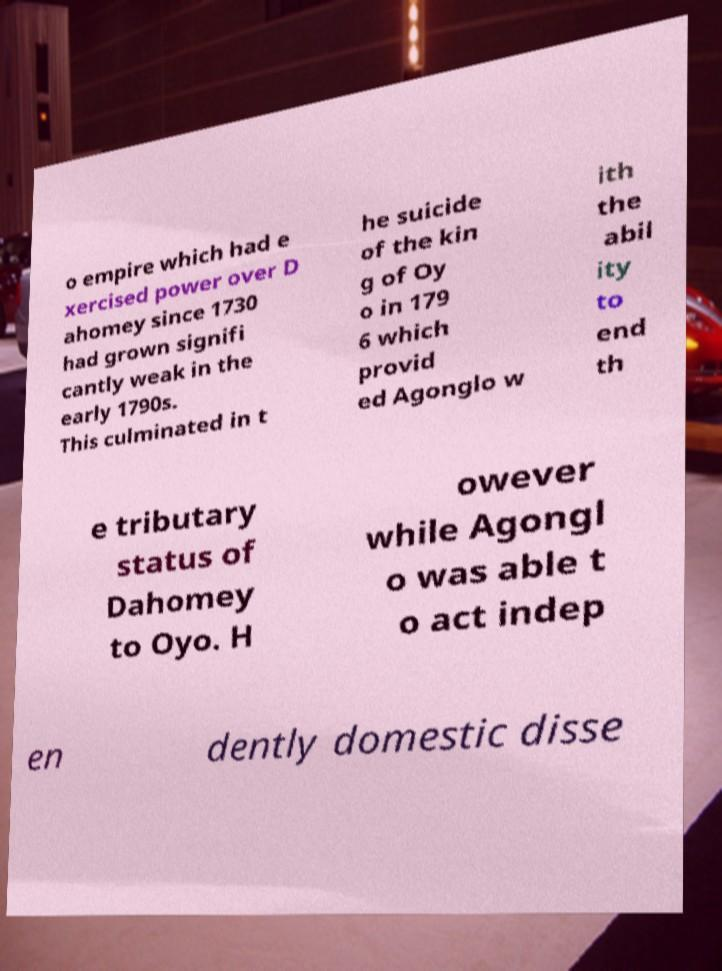Please read and relay the text visible in this image. What does it say? o empire which had e xercised power over D ahomey since 1730 had grown signifi cantly weak in the early 1790s. This culminated in t he suicide of the kin g of Oy o in 179 6 which provid ed Agonglo w ith the abil ity to end th e tributary status of Dahomey to Oyo. H owever while Agongl o was able t o act indep en dently domestic disse 